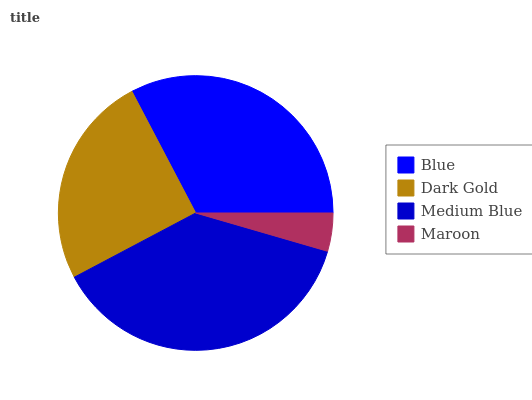Is Maroon the minimum?
Answer yes or no. Yes. Is Medium Blue the maximum?
Answer yes or no. Yes. Is Dark Gold the minimum?
Answer yes or no. No. Is Dark Gold the maximum?
Answer yes or no. No. Is Blue greater than Dark Gold?
Answer yes or no. Yes. Is Dark Gold less than Blue?
Answer yes or no. Yes. Is Dark Gold greater than Blue?
Answer yes or no. No. Is Blue less than Dark Gold?
Answer yes or no. No. Is Blue the high median?
Answer yes or no. Yes. Is Dark Gold the low median?
Answer yes or no. Yes. Is Dark Gold the high median?
Answer yes or no. No. Is Medium Blue the low median?
Answer yes or no. No. 